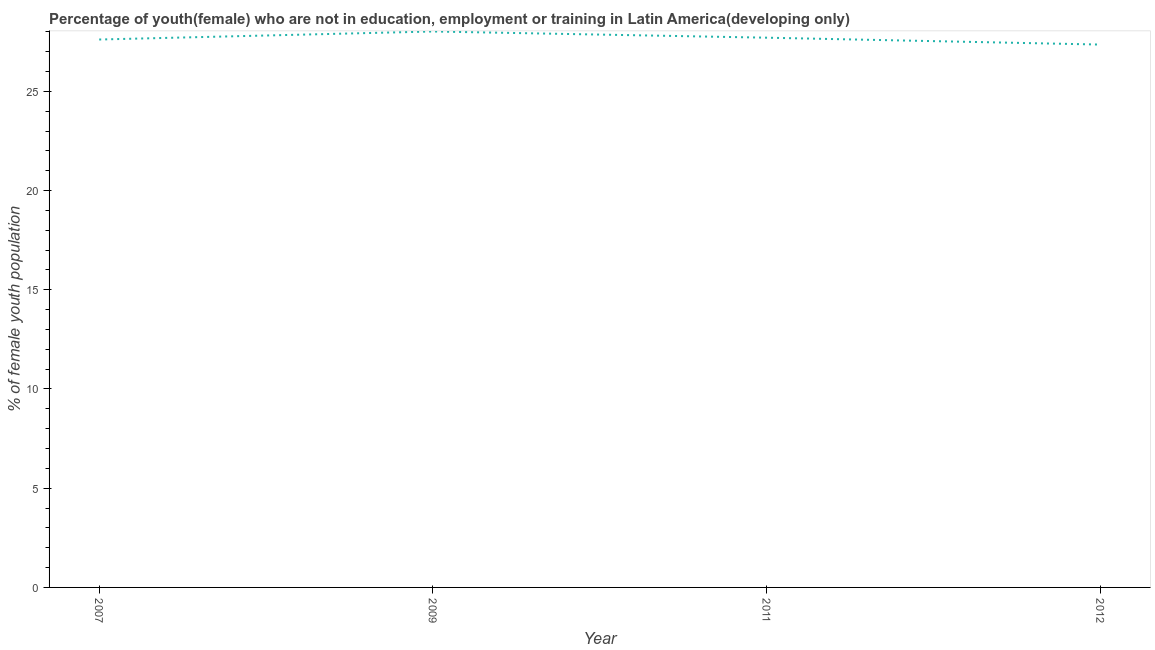What is the unemployed female youth population in 2009?
Provide a succinct answer. 28.02. Across all years, what is the maximum unemployed female youth population?
Provide a succinct answer. 28.02. Across all years, what is the minimum unemployed female youth population?
Your response must be concise. 27.36. In which year was the unemployed female youth population maximum?
Your answer should be compact. 2009. What is the sum of the unemployed female youth population?
Offer a terse response. 110.69. What is the difference between the unemployed female youth population in 2009 and 2012?
Offer a terse response. 0.66. What is the average unemployed female youth population per year?
Your answer should be compact. 27.67. What is the median unemployed female youth population?
Make the answer very short. 27.66. In how many years, is the unemployed female youth population greater than 21 %?
Offer a very short reply. 4. What is the ratio of the unemployed female youth population in 2009 to that in 2012?
Provide a short and direct response. 1.02. What is the difference between the highest and the second highest unemployed female youth population?
Provide a succinct answer. 0.31. What is the difference between the highest and the lowest unemployed female youth population?
Your answer should be compact. 0.66. In how many years, is the unemployed female youth population greater than the average unemployed female youth population taken over all years?
Offer a very short reply. 2. Does the unemployed female youth population monotonically increase over the years?
Keep it short and to the point. No. What is the difference between two consecutive major ticks on the Y-axis?
Ensure brevity in your answer.  5. Does the graph contain any zero values?
Offer a very short reply. No. What is the title of the graph?
Your answer should be compact. Percentage of youth(female) who are not in education, employment or training in Latin America(developing only). What is the label or title of the Y-axis?
Provide a succinct answer. % of female youth population. What is the % of female youth population in 2007?
Your answer should be very brief. 27.61. What is the % of female youth population of 2009?
Ensure brevity in your answer.  28.02. What is the % of female youth population of 2011?
Ensure brevity in your answer.  27.7. What is the % of female youth population of 2012?
Your response must be concise. 27.36. What is the difference between the % of female youth population in 2007 and 2009?
Keep it short and to the point. -0.4. What is the difference between the % of female youth population in 2007 and 2011?
Make the answer very short. -0.09. What is the difference between the % of female youth population in 2007 and 2012?
Your response must be concise. 0.25. What is the difference between the % of female youth population in 2009 and 2011?
Make the answer very short. 0.31. What is the difference between the % of female youth population in 2009 and 2012?
Keep it short and to the point. 0.66. What is the difference between the % of female youth population in 2011 and 2012?
Provide a succinct answer. 0.35. 